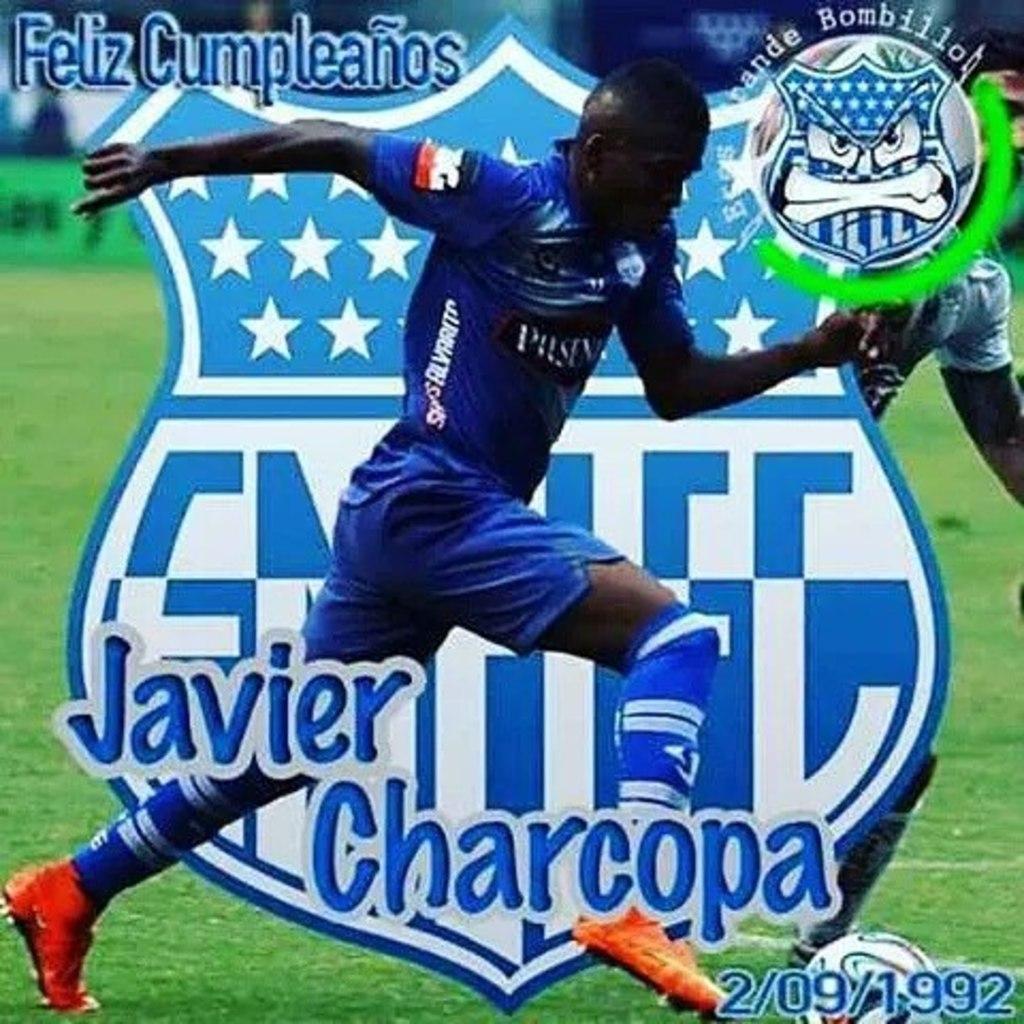Who is this soccer player?
Keep it short and to the point. Javier charcopa. What is the date on the photo?
Offer a very short reply. 2/09/1992. 